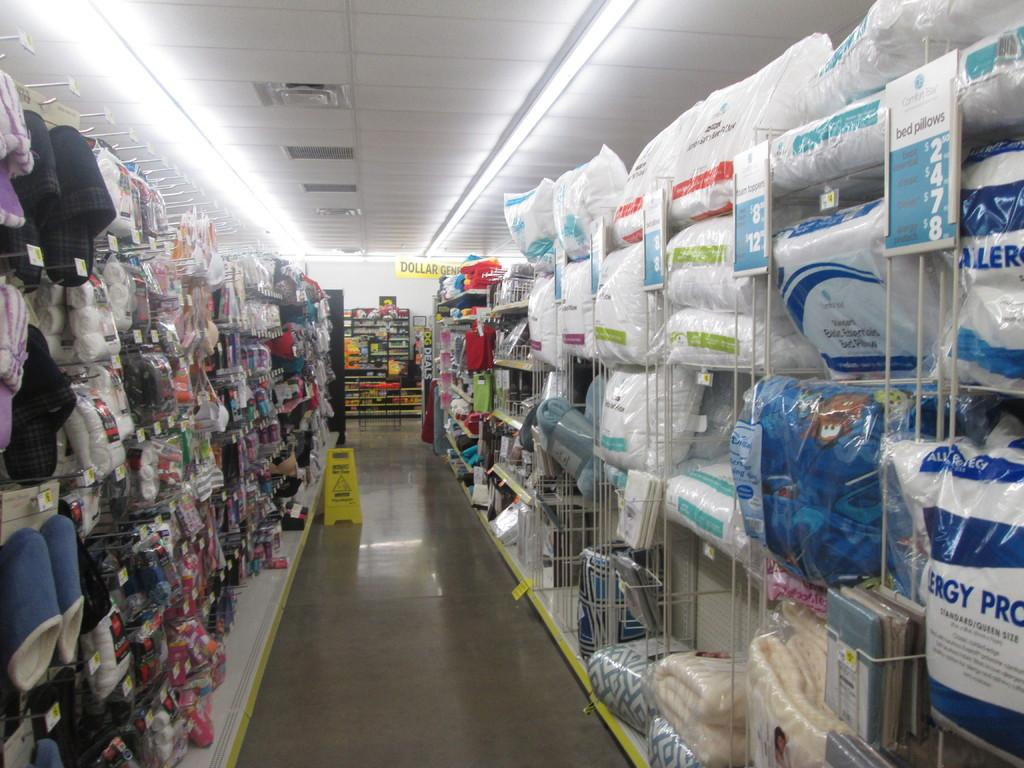Provide a one-sentence caption for the provided image. The blue sign tells us that pillows range from $2.50 to $8. 